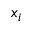Convert formula to latex. <formula><loc_0><loc_0><loc_500><loc_500>x _ { i }</formula> 